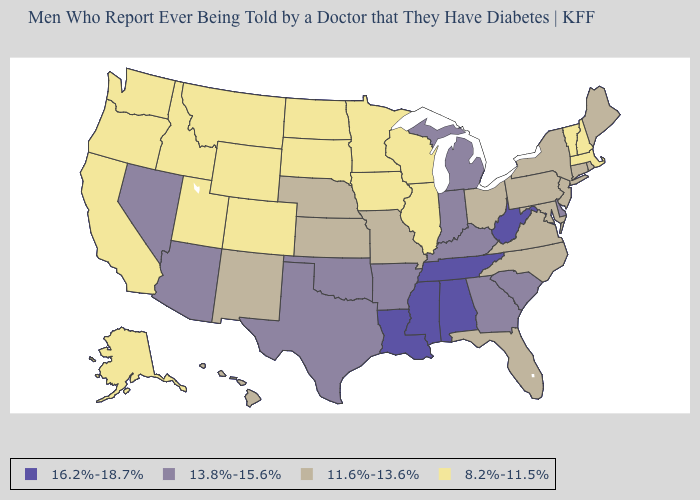What is the value of Oregon?
Short answer required. 8.2%-11.5%. What is the lowest value in the Northeast?
Answer briefly. 8.2%-11.5%. What is the value of Pennsylvania?
Write a very short answer. 11.6%-13.6%. What is the value of Colorado?
Short answer required. 8.2%-11.5%. Which states have the lowest value in the USA?
Give a very brief answer. Alaska, California, Colorado, Idaho, Illinois, Iowa, Massachusetts, Minnesota, Montana, New Hampshire, North Dakota, Oregon, South Dakota, Utah, Vermont, Washington, Wisconsin, Wyoming. Does Oklahoma have the lowest value in the USA?
Answer briefly. No. Which states have the highest value in the USA?
Write a very short answer. Alabama, Louisiana, Mississippi, Tennessee, West Virginia. What is the value of Oregon?
Short answer required. 8.2%-11.5%. What is the highest value in the West ?
Quick response, please. 13.8%-15.6%. Name the states that have a value in the range 13.8%-15.6%?
Quick response, please. Arizona, Arkansas, Delaware, Georgia, Indiana, Kentucky, Michigan, Nevada, Oklahoma, South Carolina, Texas. What is the highest value in states that border Illinois?
Quick response, please. 13.8%-15.6%. Does Maryland have the same value as South Carolina?
Give a very brief answer. No. Does Pennsylvania have a higher value than Oregon?
Keep it brief. Yes. 